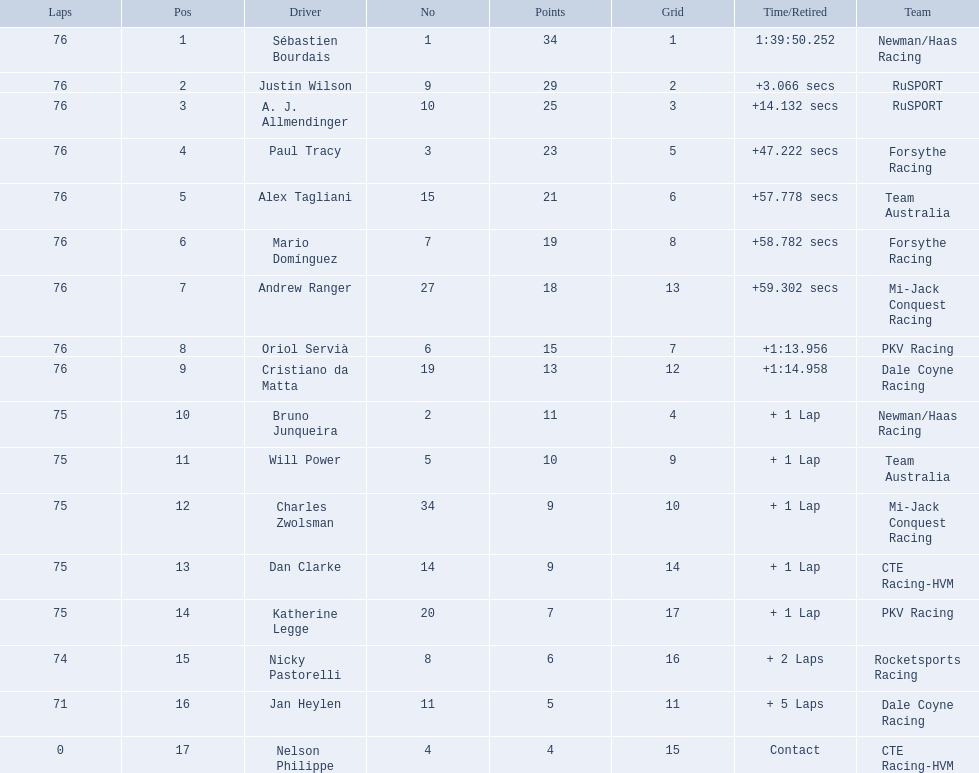How many points did charles zwolsman acquire? 9. Who else got 9 points? Dan Clarke. 